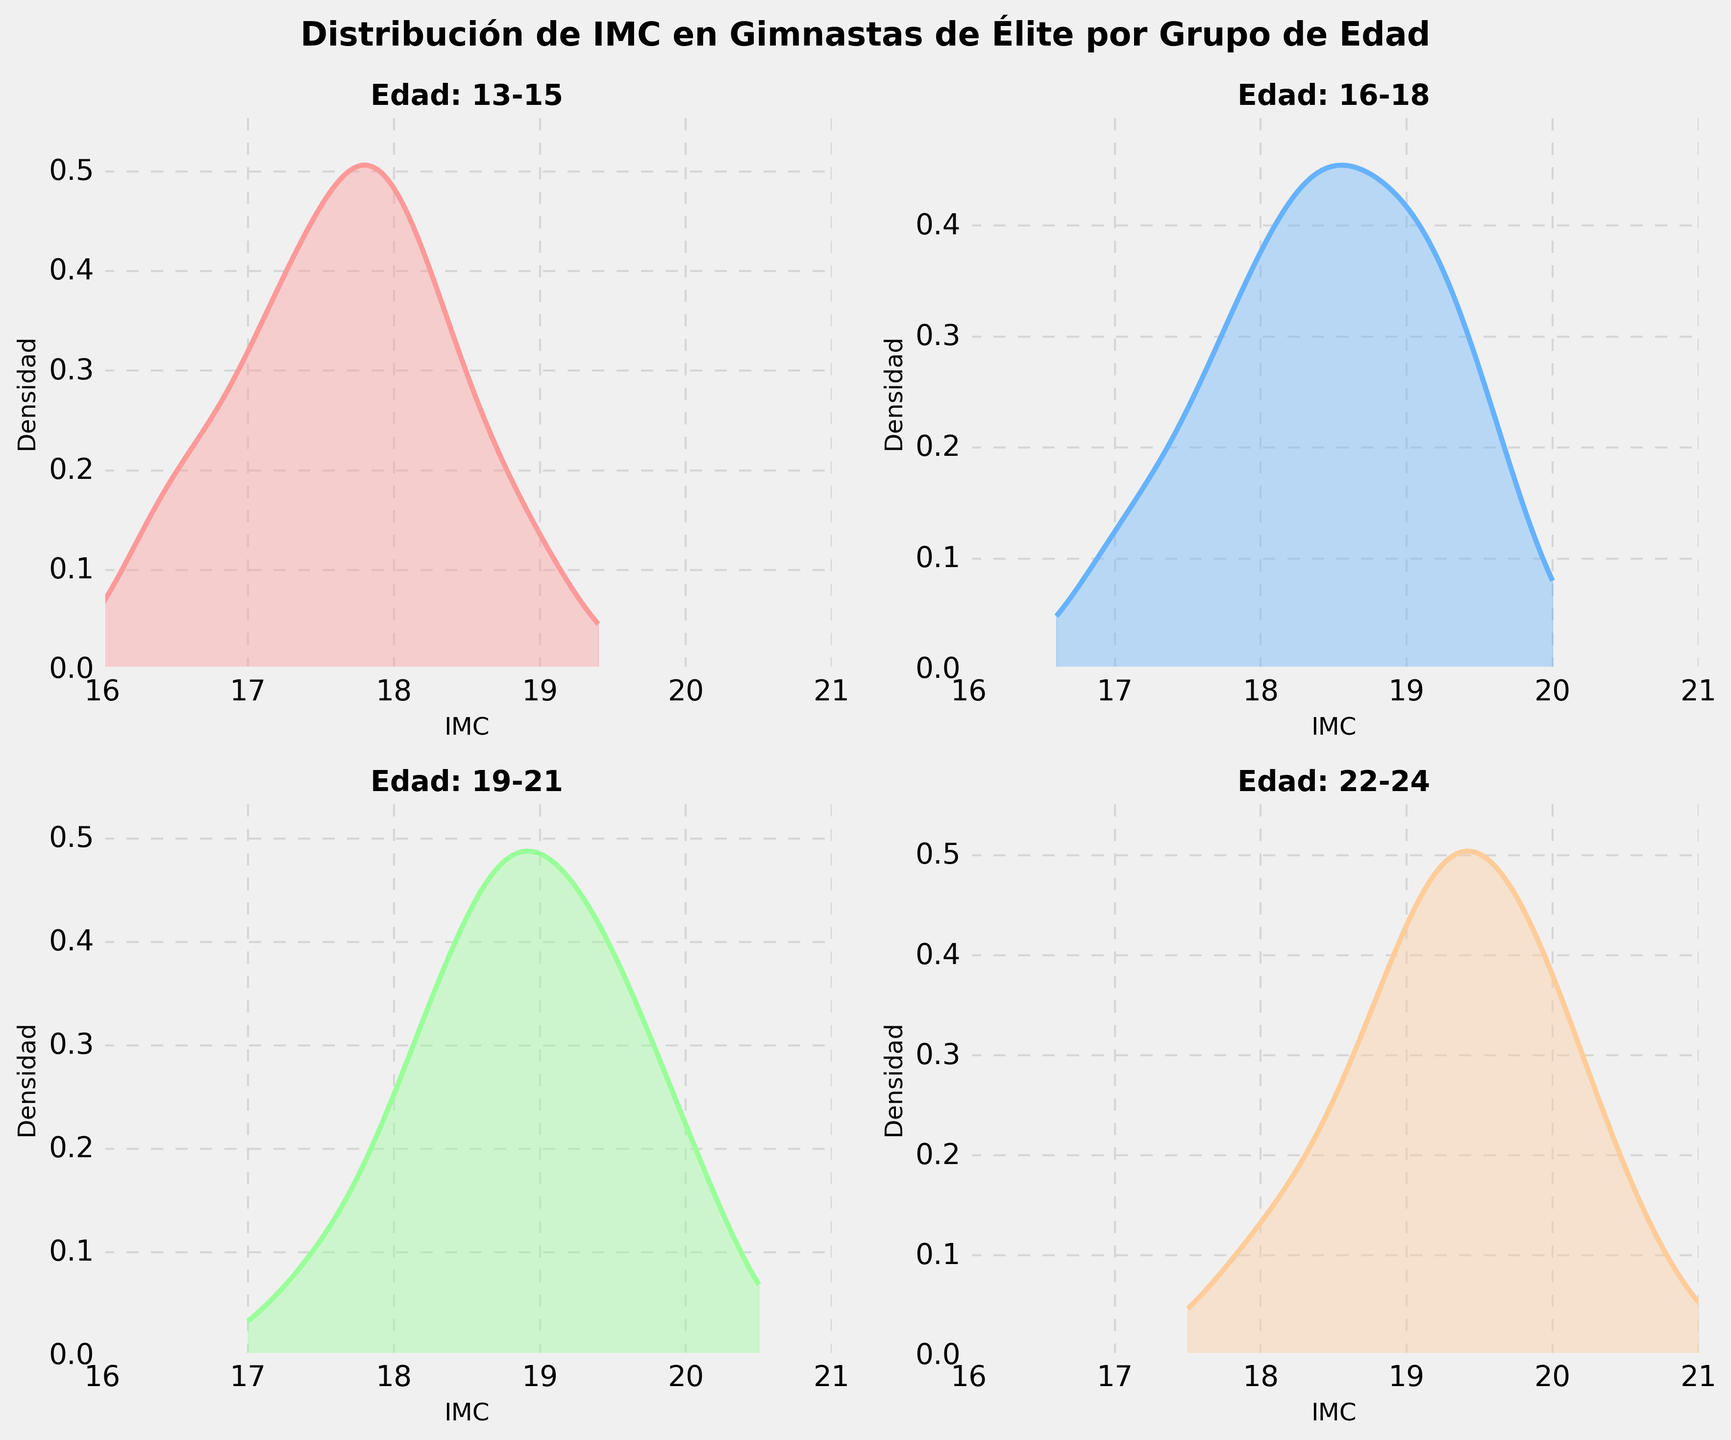What is the title of the figure? The title is typically located at the top center of the figure. It provides a summary of what the figure is about. In this case, the title is displayed clearly at the top of the plot.
Answer: Distribución de IMC en Gimnastas de Élite por Grupo de Edad What does the x-axis represent in all subplots? The x-axis label in each subplot indicates what the horizontal axis represents. Here, each subplot has "IMC" labeled on the x-axis, which stands for Body Mass Index.
Answer: IMC Which age group has the highest peak density? The highest peak density can be determined by comparing the highest points of the curves in each subplot. The subplot for the 16-18 age group has the highest peak density.
Answer: 16-18 What is the color used for the density plot of the 13-15 age group? The color of each density plot can be identified visually. The subplot for the 13-15 age group uses a shade of red or pink.
Answer: Red/Pink What is the approximate range of BMI values represented in the subplots? The range of BMI values can be determined by examining the x-axis of all subplots, which extends from approximately 16 to 21.
Answer: 16-21 Which age group displays a wider distribution of BMI values? To determine the wider distribution, look at the spread of the curves. The 22-24 age group displays a wider distribution as its curve is flatter and more spread out.
Answer: 22-24 How does the peak density for the 19-21 age group compare to that of the 13-15 age group? Compare the height of the peaks of the curves. The peak density for the 19-21 age group is lower than that of the 13-15 age group.
Answer: Lower What is the BMI value corresponding to the peak density for the 22-24 age group? The peak density occurs at the highest point in the curve of the 22-24 age group. For this group, the peak is around a BMI of 18.7.
Answer: 18.7 How many subplots are included in the figure? The figure consists of a 2x2 grid, which totals to 4 subplots, each representing a different age group.
Answer: 4 